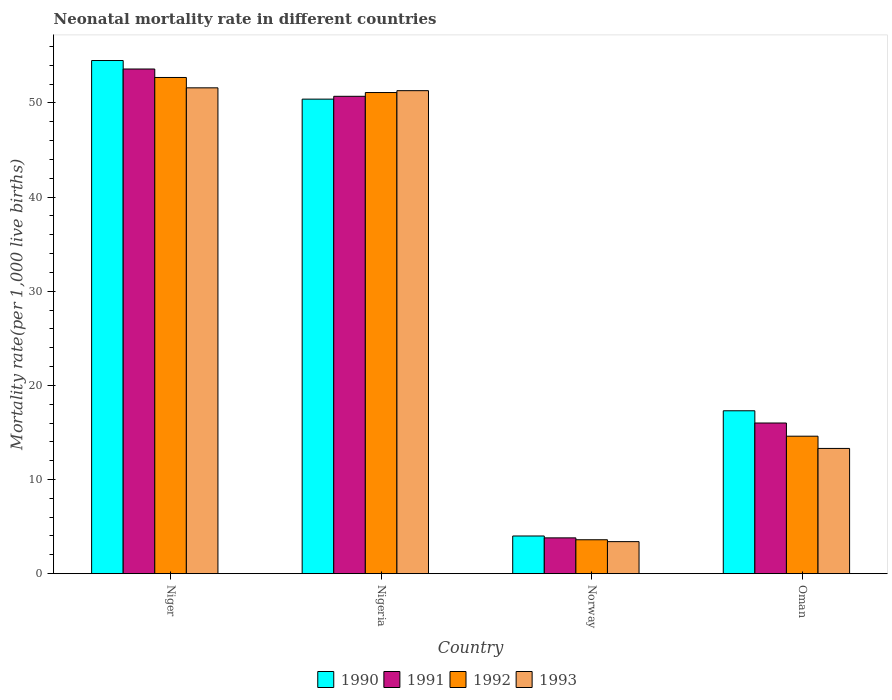How many different coloured bars are there?
Give a very brief answer. 4. What is the label of the 1st group of bars from the left?
Offer a terse response. Niger. What is the neonatal mortality rate in 1991 in Oman?
Make the answer very short. 16. Across all countries, what is the maximum neonatal mortality rate in 1990?
Give a very brief answer. 54.5. Across all countries, what is the minimum neonatal mortality rate in 1990?
Your response must be concise. 4. In which country was the neonatal mortality rate in 1992 maximum?
Ensure brevity in your answer.  Niger. In which country was the neonatal mortality rate in 1992 minimum?
Make the answer very short. Norway. What is the total neonatal mortality rate in 1990 in the graph?
Ensure brevity in your answer.  126.2. What is the difference between the neonatal mortality rate in 1992 in Nigeria and that in Norway?
Your answer should be compact. 47.5. What is the difference between the neonatal mortality rate in 1990 in Norway and the neonatal mortality rate in 1993 in Niger?
Keep it short and to the point. -47.6. What is the average neonatal mortality rate in 1991 per country?
Your response must be concise. 31.03. What is the difference between the neonatal mortality rate of/in 1991 and neonatal mortality rate of/in 1992 in Oman?
Ensure brevity in your answer.  1.4. What is the ratio of the neonatal mortality rate in 1992 in Norway to that in Oman?
Offer a very short reply. 0.25. What is the difference between the highest and the second highest neonatal mortality rate in 1993?
Your answer should be very brief. -0.3. What is the difference between the highest and the lowest neonatal mortality rate in 1991?
Keep it short and to the point. 49.8. What does the 3rd bar from the left in Oman represents?
Your response must be concise. 1992. Is it the case that in every country, the sum of the neonatal mortality rate in 1992 and neonatal mortality rate in 1990 is greater than the neonatal mortality rate in 1993?
Make the answer very short. Yes. How many bars are there?
Make the answer very short. 16. How many countries are there in the graph?
Give a very brief answer. 4. How many legend labels are there?
Your response must be concise. 4. How are the legend labels stacked?
Ensure brevity in your answer.  Horizontal. What is the title of the graph?
Ensure brevity in your answer.  Neonatal mortality rate in different countries. What is the label or title of the Y-axis?
Give a very brief answer. Mortality rate(per 1,0 live births). What is the Mortality rate(per 1,000 live births) in 1990 in Niger?
Offer a terse response. 54.5. What is the Mortality rate(per 1,000 live births) in 1991 in Niger?
Provide a short and direct response. 53.6. What is the Mortality rate(per 1,000 live births) of 1992 in Niger?
Keep it short and to the point. 52.7. What is the Mortality rate(per 1,000 live births) of 1993 in Niger?
Provide a succinct answer. 51.6. What is the Mortality rate(per 1,000 live births) of 1990 in Nigeria?
Your answer should be very brief. 50.4. What is the Mortality rate(per 1,000 live births) of 1991 in Nigeria?
Your answer should be compact. 50.7. What is the Mortality rate(per 1,000 live births) in 1992 in Nigeria?
Your answer should be very brief. 51.1. What is the Mortality rate(per 1,000 live births) in 1993 in Nigeria?
Your answer should be compact. 51.3. What is the Mortality rate(per 1,000 live births) of 1990 in Norway?
Ensure brevity in your answer.  4. What is the Mortality rate(per 1,000 live births) of 1992 in Norway?
Your answer should be very brief. 3.6. What is the Mortality rate(per 1,000 live births) of 1993 in Oman?
Offer a very short reply. 13.3. Across all countries, what is the maximum Mortality rate(per 1,000 live births) of 1990?
Offer a terse response. 54.5. Across all countries, what is the maximum Mortality rate(per 1,000 live births) in 1991?
Your response must be concise. 53.6. Across all countries, what is the maximum Mortality rate(per 1,000 live births) in 1992?
Make the answer very short. 52.7. Across all countries, what is the maximum Mortality rate(per 1,000 live births) in 1993?
Provide a short and direct response. 51.6. Across all countries, what is the minimum Mortality rate(per 1,000 live births) in 1993?
Give a very brief answer. 3.4. What is the total Mortality rate(per 1,000 live births) of 1990 in the graph?
Keep it short and to the point. 126.2. What is the total Mortality rate(per 1,000 live births) of 1991 in the graph?
Make the answer very short. 124.1. What is the total Mortality rate(per 1,000 live births) of 1992 in the graph?
Offer a terse response. 122. What is the total Mortality rate(per 1,000 live births) of 1993 in the graph?
Offer a very short reply. 119.6. What is the difference between the Mortality rate(per 1,000 live births) of 1990 in Niger and that in Norway?
Offer a very short reply. 50.5. What is the difference between the Mortality rate(per 1,000 live births) in 1991 in Niger and that in Norway?
Offer a terse response. 49.8. What is the difference between the Mortality rate(per 1,000 live births) of 1992 in Niger and that in Norway?
Your response must be concise. 49.1. What is the difference between the Mortality rate(per 1,000 live births) in 1993 in Niger and that in Norway?
Provide a short and direct response. 48.2. What is the difference between the Mortality rate(per 1,000 live births) in 1990 in Niger and that in Oman?
Your response must be concise. 37.2. What is the difference between the Mortality rate(per 1,000 live births) of 1991 in Niger and that in Oman?
Your response must be concise. 37.6. What is the difference between the Mortality rate(per 1,000 live births) in 1992 in Niger and that in Oman?
Offer a very short reply. 38.1. What is the difference between the Mortality rate(per 1,000 live births) in 1993 in Niger and that in Oman?
Make the answer very short. 38.3. What is the difference between the Mortality rate(per 1,000 live births) of 1990 in Nigeria and that in Norway?
Provide a short and direct response. 46.4. What is the difference between the Mortality rate(per 1,000 live births) in 1991 in Nigeria and that in Norway?
Make the answer very short. 46.9. What is the difference between the Mortality rate(per 1,000 live births) of 1992 in Nigeria and that in Norway?
Ensure brevity in your answer.  47.5. What is the difference between the Mortality rate(per 1,000 live births) in 1993 in Nigeria and that in Norway?
Keep it short and to the point. 47.9. What is the difference between the Mortality rate(per 1,000 live births) of 1990 in Nigeria and that in Oman?
Offer a terse response. 33.1. What is the difference between the Mortality rate(per 1,000 live births) of 1991 in Nigeria and that in Oman?
Your answer should be very brief. 34.7. What is the difference between the Mortality rate(per 1,000 live births) in 1992 in Nigeria and that in Oman?
Your answer should be compact. 36.5. What is the difference between the Mortality rate(per 1,000 live births) of 1993 in Nigeria and that in Oman?
Offer a very short reply. 38. What is the difference between the Mortality rate(per 1,000 live births) in 1990 in Norway and that in Oman?
Provide a succinct answer. -13.3. What is the difference between the Mortality rate(per 1,000 live births) in 1992 in Norway and that in Oman?
Keep it short and to the point. -11. What is the difference between the Mortality rate(per 1,000 live births) of 1990 in Niger and the Mortality rate(per 1,000 live births) of 1991 in Nigeria?
Ensure brevity in your answer.  3.8. What is the difference between the Mortality rate(per 1,000 live births) in 1991 in Niger and the Mortality rate(per 1,000 live births) in 1993 in Nigeria?
Keep it short and to the point. 2.3. What is the difference between the Mortality rate(per 1,000 live births) in 1990 in Niger and the Mortality rate(per 1,000 live births) in 1991 in Norway?
Your answer should be compact. 50.7. What is the difference between the Mortality rate(per 1,000 live births) in 1990 in Niger and the Mortality rate(per 1,000 live births) in 1992 in Norway?
Your answer should be compact. 50.9. What is the difference between the Mortality rate(per 1,000 live births) of 1990 in Niger and the Mortality rate(per 1,000 live births) of 1993 in Norway?
Provide a short and direct response. 51.1. What is the difference between the Mortality rate(per 1,000 live births) in 1991 in Niger and the Mortality rate(per 1,000 live births) in 1992 in Norway?
Offer a very short reply. 50. What is the difference between the Mortality rate(per 1,000 live births) of 1991 in Niger and the Mortality rate(per 1,000 live births) of 1993 in Norway?
Your answer should be compact. 50.2. What is the difference between the Mortality rate(per 1,000 live births) in 1992 in Niger and the Mortality rate(per 1,000 live births) in 1993 in Norway?
Offer a very short reply. 49.3. What is the difference between the Mortality rate(per 1,000 live births) of 1990 in Niger and the Mortality rate(per 1,000 live births) of 1991 in Oman?
Ensure brevity in your answer.  38.5. What is the difference between the Mortality rate(per 1,000 live births) of 1990 in Niger and the Mortality rate(per 1,000 live births) of 1992 in Oman?
Keep it short and to the point. 39.9. What is the difference between the Mortality rate(per 1,000 live births) in 1990 in Niger and the Mortality rate(per 1,000 live births) in 1993 in Oman?
Provide a short and direct response. 41.2. What is the difference between the Mortality rate(per 1,000 live births) of 1991 in Niger and the Mortality rate(per 1,000 live births) of 1993 in Oman?
Make the answer very short. 40.3. What is the difference between the Mortality rate(per 1,000 live births) in 1992 in Niger and the Mortality rate(per 1,000 live births) in 1993 in Oman?
Give a very brief answer. 39.4. What is the difference between the Mortality rate(per 1,000 live births) in 1990 in Nigeria and the Mortality rate(per 1,000 live births) in 1991 in Norway?
Make the answer very short. 46.6. What is the difference between the Mortality rate(per 1,000 live births) of 1990 in Nigeria and the Mortality rate(per 1,000 live births) of 1992 in Norway?
Make the answer very short. 46.8. What is the difference between the Mortality rate(per 1,000 live births) in 1990 in Nigeria and the Mortality rate(per 1,000 live births) in 1993 in Norway?
Ensure brevity in your answer.  47. What is the difference between the Mortality rate(per 1,000 live births) of 1991 in Nigeria and the Mortality rate(per 1,000 live births) of 1992 in Norway?
Make the answer very short. 47.1. What is the difference between the Mortality rate(per 1,000 live births) of 1991 in Nigeria and the Mortality rate(per 1,000 live births) of 1993 in Norway?
Make the answer very short. 47.3. What is the difference between the Mortality rate(per 1,000 live births) in 1992 in Nigeria and the Mortality rate(per 1,000 live births) in 1993 in Norway?
Make the answer very short. 47.7. What is the difference between the Mortality rate(per 1,000 live births) in 1990 in Nigeria and the Mortality rate(per 1,000 live births) in 1991 in Oman?
Your answer should be compact. 34.4. What is the difference between the Mortality rate(per 1,000 live births) of 1990 in Nigeria and the Mortality rate(per 1,000 live births) of 1992 in Oman?
Give a very brief answer. 35.8. What is the difference between the Mortality rate(per 1,000 live births) of 1990 in Nigeria and the Mortality rate(per 1,000 live births) of 1993 in Oman?
Offer a very short reply. 37.1. What is the difference between the Mortality rate(per 1,000 live births) in 1991 in Nigeria and the Mortality rate(per 1,000 live births) in 1992 in Oman?
Your response must be concise. 36.1. What is the difference between the Mortality rate(per 1,000 live births) of 1991 in Nigeria and the Mortality rate(per 1,000 live births) of 1993 in Oman?
Give a very brief answer. 37.4. What is the difference between the Mortality rate(per 1,000 live births) of 1992 in Nigeria and the Mortality rate(per 1,000 live births) of 1993 in Oman?
Provide a short and direct response. 37.8. What is the difference between the Mortality rate(per 1,000 live births) of 1990 in Norway and the Mortality rate(per 1,000 live births) of 1991 in Oman?
Provide a short and direct response. -12. What is the difference between the Mortality rate(per 1,000 live births) of 1990 in Norway and the Mortality rate(per 1,000 live births) of 1992 in Oman?
Keep it short and to the point. -10.6. What is the difference between the Mortality rate(per 1,000 live births) in 1990 in Norway and the Mortality rate(per 1,000 live births) in 1993 in Oman?
Provide a short and direct response. -9.3. What is the average Mortality rate(per 1,000 live births) in 1990 per country?
Your response must be concise. 31.55. What is the average Mortality rate(per 1,000 live births) in 1991 per country?
Give a very brief answer. 31.02. What is the average Mortality rate(per 1,000 live births) of 1992 per country?
Your response must be concise. 30.5. What is the average Mortality rate(per 1,000 live births) of 1993 per country?
Ensure brevity in your answer.  29.9. What is the difference between the Mortality rate(per 1,000 live births) in 1990 and Mortality rate(per 1,000 live births) in 1992 in Niger?
Give a very brief answer. 1.8. What is the difference between the Mortality rate(per 1,000 live births) of 1992 and Mortality rate(per 1,000 live births) of 1993 in Niger?
Make the answer very short. 1.1. What is the difference between the Mortality rate(per 1,000 live births) of 1991 and Mortality rate(per 1,000 live births) of 1993 in Nigeria?
Your response must be concise. -0.6. What is the difference between the Mortality rate(per 1,000 live births) of 1992 and Mortality rate(per 1,000 live births) of 1993 in Nigeria?
Offer a terse response. -0.2. What is the difference between the Mortality rate(per 1,000 live births) in 1991 and Mortality rate(per 1,000 live births) in 1992 in Norway?
Provide a short and direct response. 0.2. What is the difference between the Mortality rate(per 1,000 live births) of 1990 and Mortality rate(per 1,000 live births) of 1991 in Oman?
Give a very brief answer. 1.3. What is the difference between the Mortality rate(per 1,000 live births) in 1990 and Mortality rate(per 1,000 live births) in 1992 in Oman?
Keep it short and to the point. 2.7. What is the ratio of the Mortality rate(per 1,000 live births) of 1990 in Niger to that in Nigeria?
Keep it short and to the point. 1.08. What is the ratio of the Mortality rate(per 1,000 live births) of 1991 in Niger to that in Nigeria?
Offer a very short reply. 1.06. What is the ratio of the Mortality rate(per 1,000 live births) of 1992 in Niger to that in Nigeria?
Ensure brevity in your answer.  1.03. What is the ratio of the Mortality rate(per 1,000 live births) in 1993 in Niger to that in Nigeria?
Ensure brevity in your answer.  1.01. What is the ratio of the Mortality rate(per 1,000 live births) of 1990 in Niger to that in Norway?
Make the answer very short. 13.62. What is the ratio of the Mortality rate(per 1,000 live births) in 1991 in Niger to that in Norway?
Make the answer very short. 14.11. What is the ratio of the Mortality rate(per 1,000 live births) of 1992 in Niger to that in Norway?
Give a very brief answer. 14.64. What is the ratio of the Mortality rate(per 1,000 live births) in 1993 in Niger to that in Norway?
Give a very brief answer. 15.18. What is the ratio of the Mortality rate(per 1,000 live births) in 1990 in Niger to that in Oman?
Keep it short and to the point. 3.15. What is the ratio of the Mortality rate(per 1,000 live births) of 1991 in Niger to that in Oman?
Your answer should be very brief. 3.35. What is the ratio of the Mortality rate(per 1,000 live births) in 1992 in Niger to that in Oman?
Give a very brief answer. 3.61. What is the ratio of the Mortality rate(per 1,000 live births) in 1993 in Niger to that in Oman?
Offer a terse response. 3.88. What is the ratio of the Mortality rate(per 1,000 live births) in 1991 in Nigeria to that in Norway?
Offer a terse response. 13.34. What is the ratio of the Mortality rate(per 1,000 live births) of 1992 in Nigeria to that in Norway?
Provide a succinct answer. 14.19. What is the ratio of the Mortality rate(per 1,000 live births) of 1993 in Nigeria to that in Norway?
Provide a short and direct response. 15.09. What is the ratio of the Mortality rate(per 1,000 live births) in 1990 in Nigeria to that in Oman?
Keep it short and to the point. 2.91. What is the ratio of the Mortality rate(per 1,000 live births) in 1991 in Nigeria to that in Oman?
Your response must be concise. 3.17. What is the ratio of the Mortality rate(per 1,000 live births) in 1993 in Nigeria to that in Oman?
Your response must be concise. 3.86. What is the ratio of the Mortality rate(per 1,000 live births) of 1990 in Norway to that in Oman?
Give a very brief answer. 0.23. What is the ratio of the Mortality rate(per 1,000 live births) in 1991 in Norway to that in Oman?
Make the answer very short. 0.24. What is the ratio of the Mortality rate(per 1,000 live births) of 1992 in Norway to that in Oman?
Ensure brevity in your answer.  0.25. What is the ratio of the Mortality rate(per 1,000 live births) of 1993 in Norway to that in Oman?
Offer a very short reply. 0.26. What is the difference between the highest and the second highest Mortality rate(per 1,000 live births) in 1990?
Your answer should be very brief. 4.1. What is the difference between the highest and the second highest Mortality rate(per 1,000 live births) of 1991?
Provide a short and direct response. 2.9. What is the difference between the highest and the lowest Mortality rate(per 1,000 live births) of 1990?
Your answer should be very brief. 50.5. What is the difference between the highest and the lowest Mortality rate(per 1,000 live births) of 1991?
Ensure brevity in your answer.  49.8. What is the difference between the highest and the lowest Mortality rate(per 1,000 live births) of 1992?
Make the answer very short. 49.1. What is the difference between the highest and the lowest Mortality rate(per 1,000 live births) in 1993?
Provide a succinct answer. 48.2. 